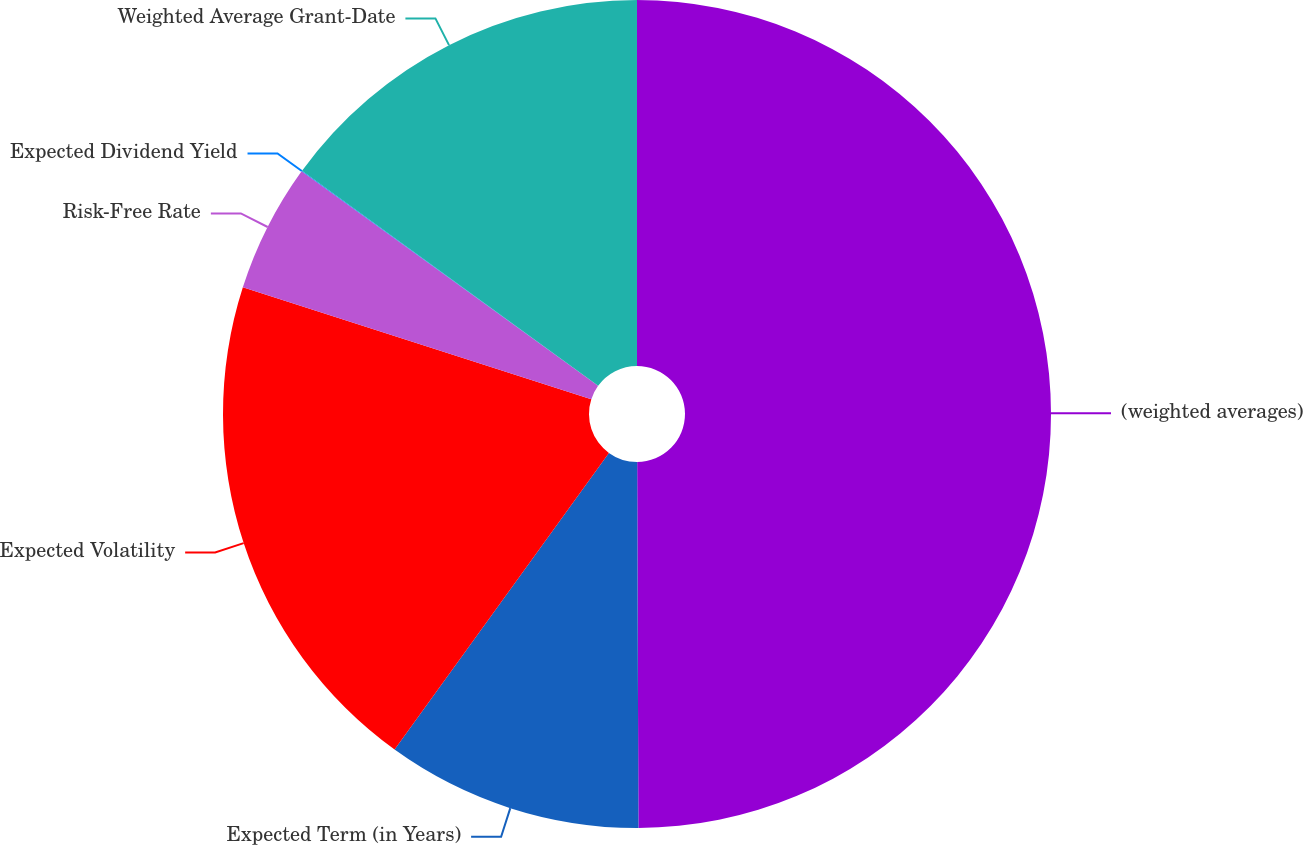Convert chart. <chart><loc_0><loc_0><loc_500><loc_500><pie_chart><fcel>(weighted averages)<fcel>Expected Term (in Years)<fcel>Expected Volatility<fcel>Risk-Free Rate<fcel>Expected Dividend Yield<fcel>Weighted Average Grant-Date<nl><fcel>49.94%<fcel>10.01%<fcel>19.99%<fcel>5.02%<fcel>0.03%<fcel>15.0%<nl></chart> 